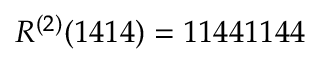<formula> <loc_0><loc_0><loc_500><loc_500>R ^ { ( 2 ) } ( 1 4 1 4 ) = 1 1 4 4 1 1 4 4</formula> 